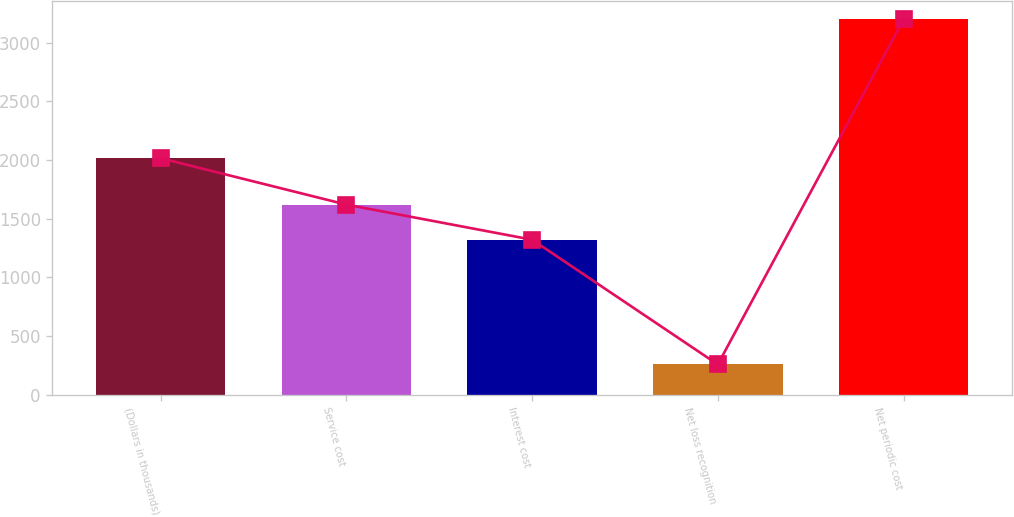<chart> <loc_0><loc_0><loc_500><loc_500><bar_chart><fcel>(Dollars in thousands)<fcel>Service cost<fcel>Interest cost<fcel>Net loss recognition<fcel>Net periodic cost<nl><fcel>2014<fcel>1619<fcel>1320<fcel>257<fcel>3196<nl></chart> 